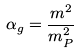<formula> <loc_0><loc_0><loc_500><loc_500>\alpha _ { g } = \frac { m ^ { 2 } } { m _ { P } ^ { 2 } }</formula> 